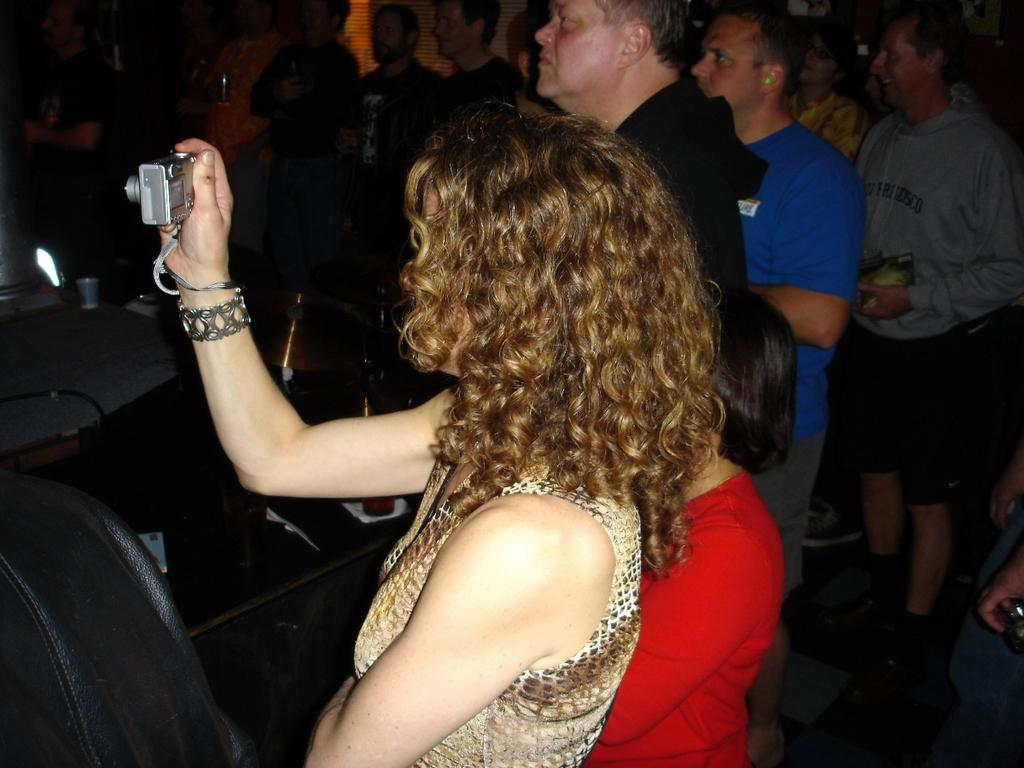What can be observed about the people in the image? There are people standing in the image. Can you describe the woman in the image? There is a woman in the image, and she is holding a camera. What type of line is visible in the image? There is no line visible in the image. What kind of structure can be seen in the background of the image? The provided facts do not mention any structure in the background of the image. 